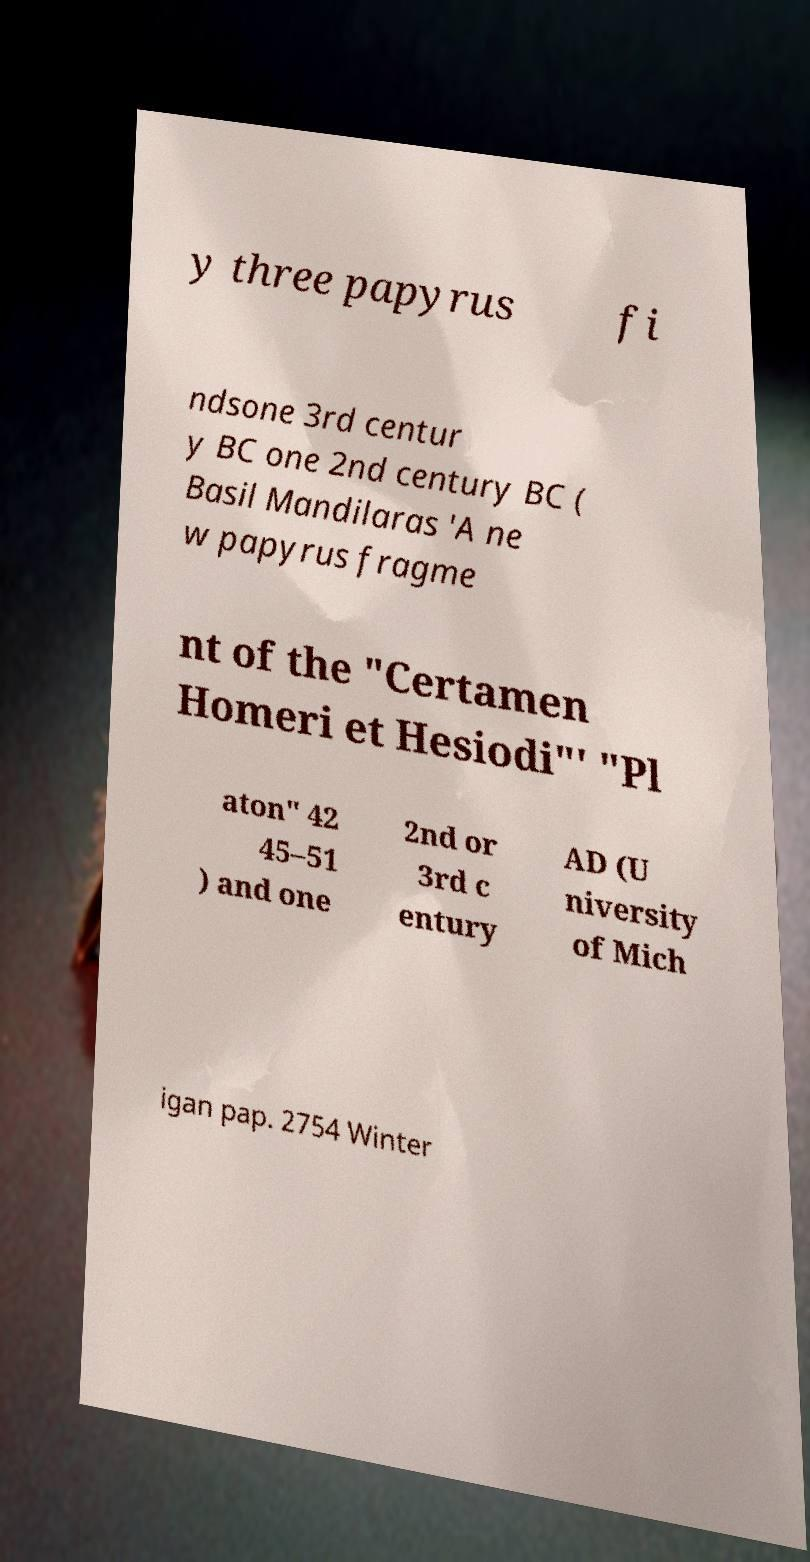Could you extract and type out the text from this image? y three papyrus fi ndsone 3rd centur y BC one 2nd century BC ( Basil Mandilaras 'A ne w papyrus fragme nt of the "Certamen Homeri et Hesiodi"' "Pl aton" 42 45–51 ) and one 2nd or 3rd c entury AD (U niversity of Mich igan pap. 2754 Winter 